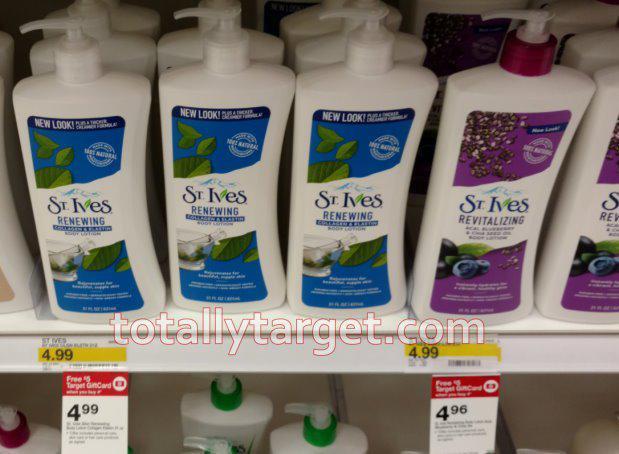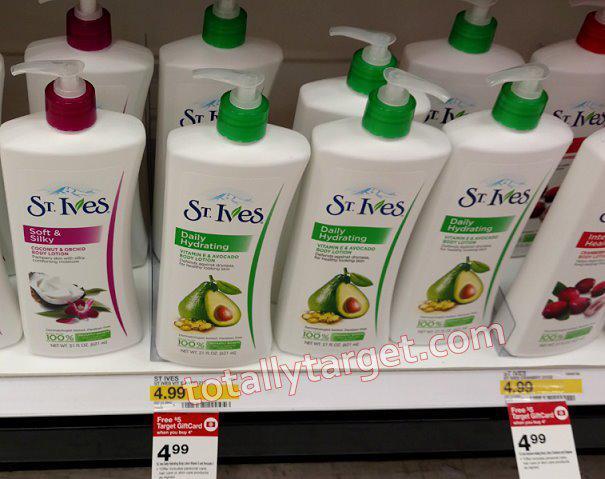The first image is the image on the left, the second image is the image on the right. Evaluate the accuracy of this statement regarding the images: "There is a hand holding product next to the shelf that shows the sales prices, on the wrist is a watch". Is it true? Answer yes or no. No. The first image is the image on the left, the second image is the image on the right. Evaluate the accuracy of this statement regarding the images: "Some price tags are green.". Is it true? Answer yes or no. No. 